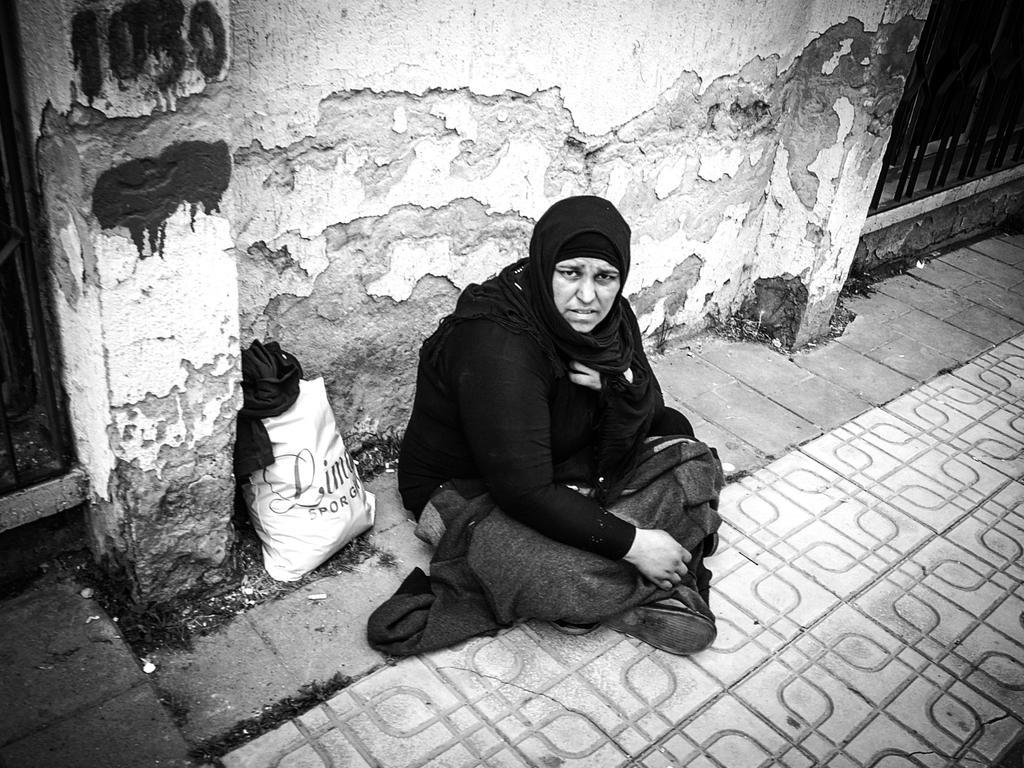Could you give a brief overview of what you see in this image? In this picture there is a woman wearing black dress is sitting on the ground and there is a cover beside her and there is a wall behind her and there is a fence in the right corner. 